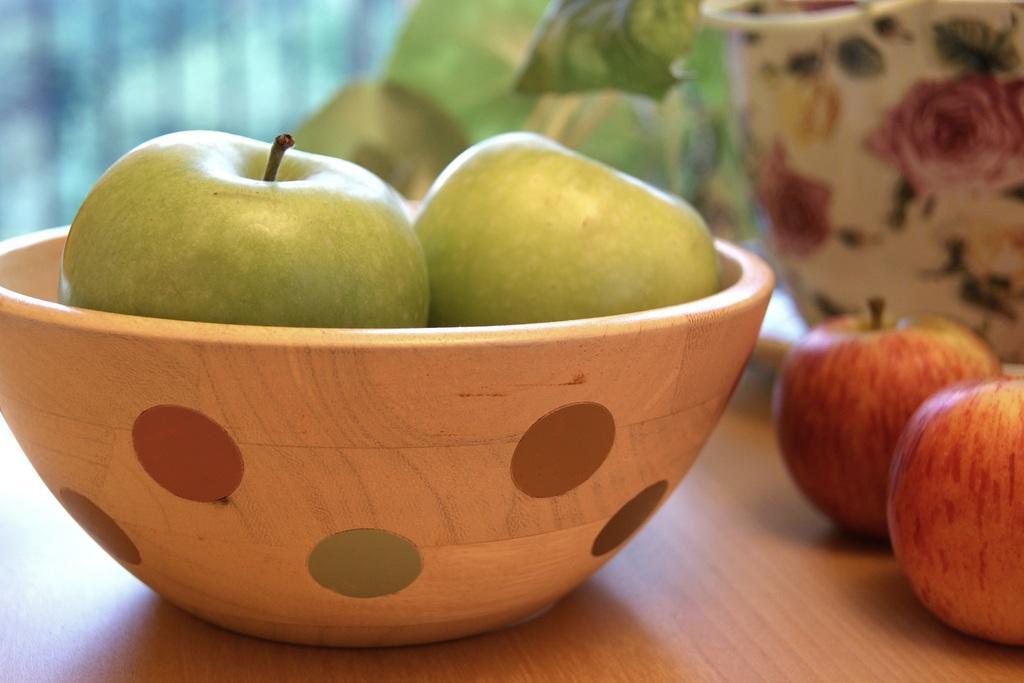Please provide a concise description of this image. In the foreground I can see a bowl in which there are apples and jars which are kept on the table. In the background I can see a wall. This image is taken may be in a room. 